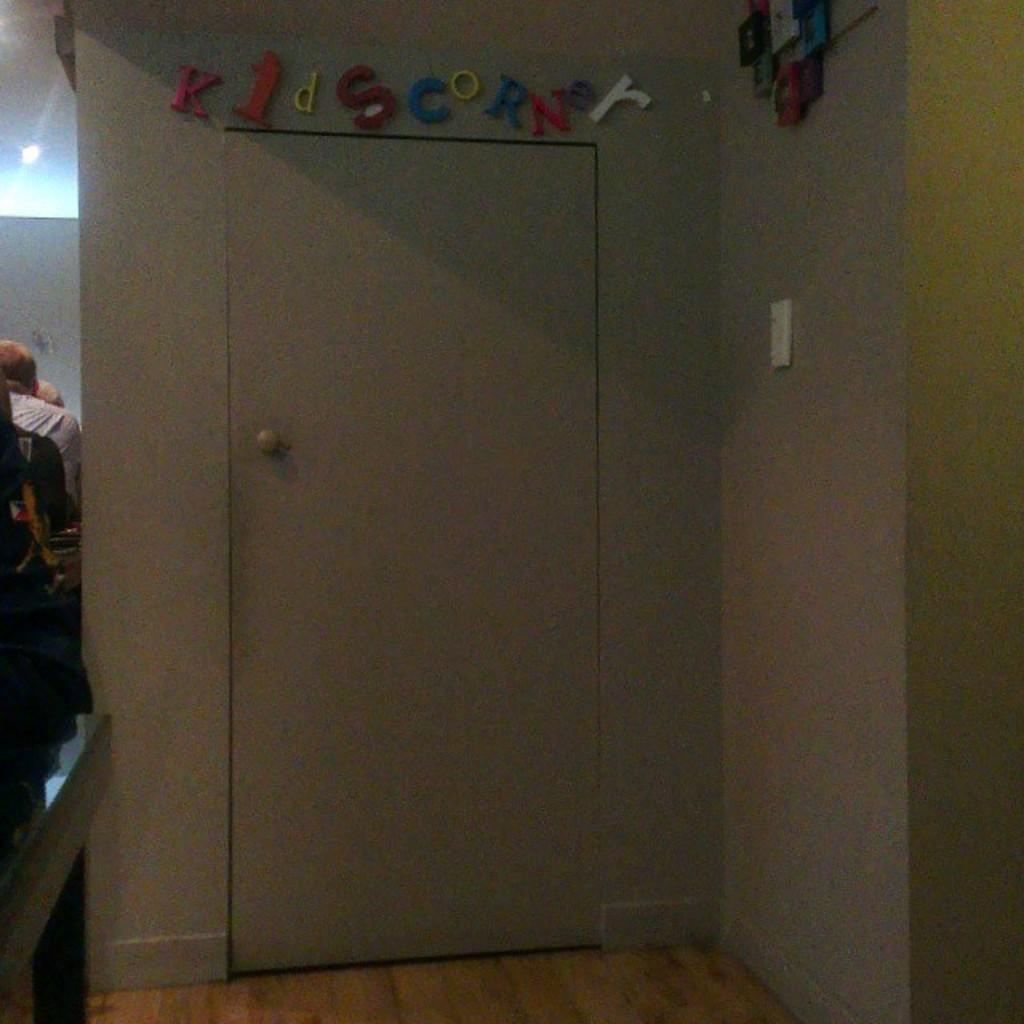What is located at the front of the image? There is a door in the front of the image. What can be seen on the right side of the image? There is a wall on the right side of the image. What is the person in the image doing? There is a person sitting on the left side of the image. Where is the light source located in the image? There is a light at the left top of the image. What type of note is the person holding in the image? There is no note present in the image; the person is simply sitting. What authority figure is depicted in the image? There is no authority figure depicted in the image; it only shows a door, a wall, a person sitting, and a light. 